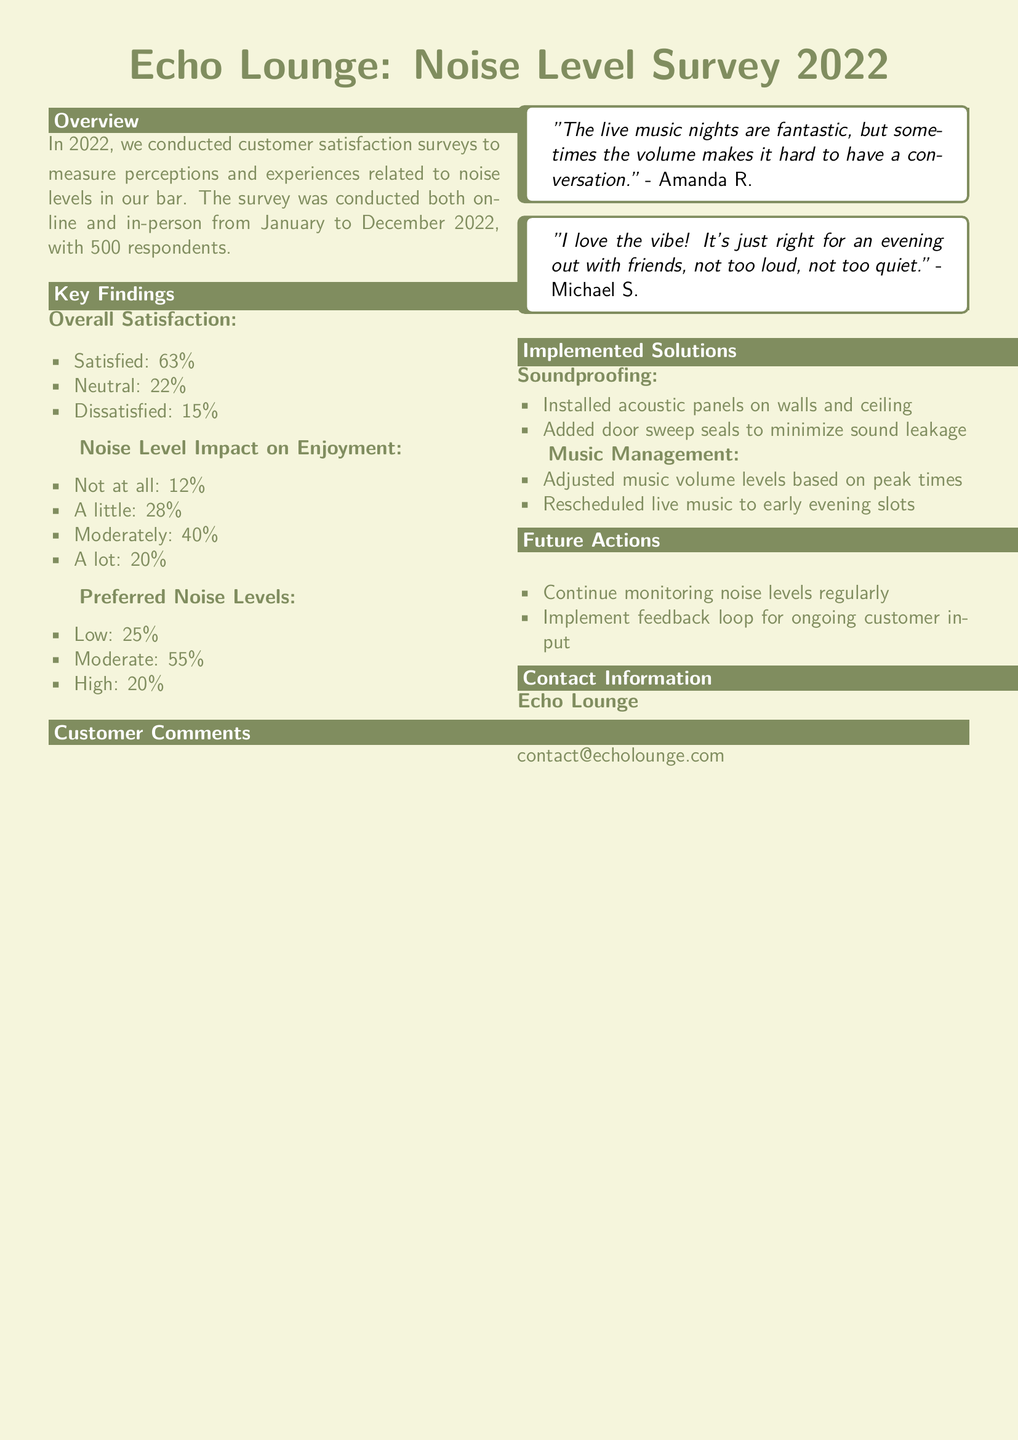What was the total number of respondents in the survey? The total number of respondents in the survey is mentioned as 500.
Answer: 500 What percentage of customers expressed dissatisfaction? The document states that 15% of customers were dissatisfied.
Answer: 15% What percentage of respondents preferred moderate noise levels? The document indicates that 55% preferred moderate noise levels.
Answer: 55% What specific solutions were implemented for soundproofing? The document lists installing acoustic panels and adding door sweep seals as soundproofing measures.
Answer: Acoustic panels, door sweep seals What did Amanda R. comment about live music nights? Amanda R. mentioned that the volume sometimes makes it hard to have a conversation.
Answer: "hard to have a conversation" What is the main action listed for future noise level management? The document mentions continuing to monitor noise levels regularly as a future action.
Answer: Monitor noise levels regularly What type of management adjustments were made regarding music? The adjustments mentioned in the document include adjusting music volume levels and rescheduling live music.
Answer: Adjust music volume, reschedule live music What was the overall customer satisfaction percentage? The overall satisfaction percentage is provided as 63%.
Answer: 63% What type of feedback mechanism is suggested for ongoing customer input? The document suggests implementing a feedback loop.
Answer: Feedback loop 